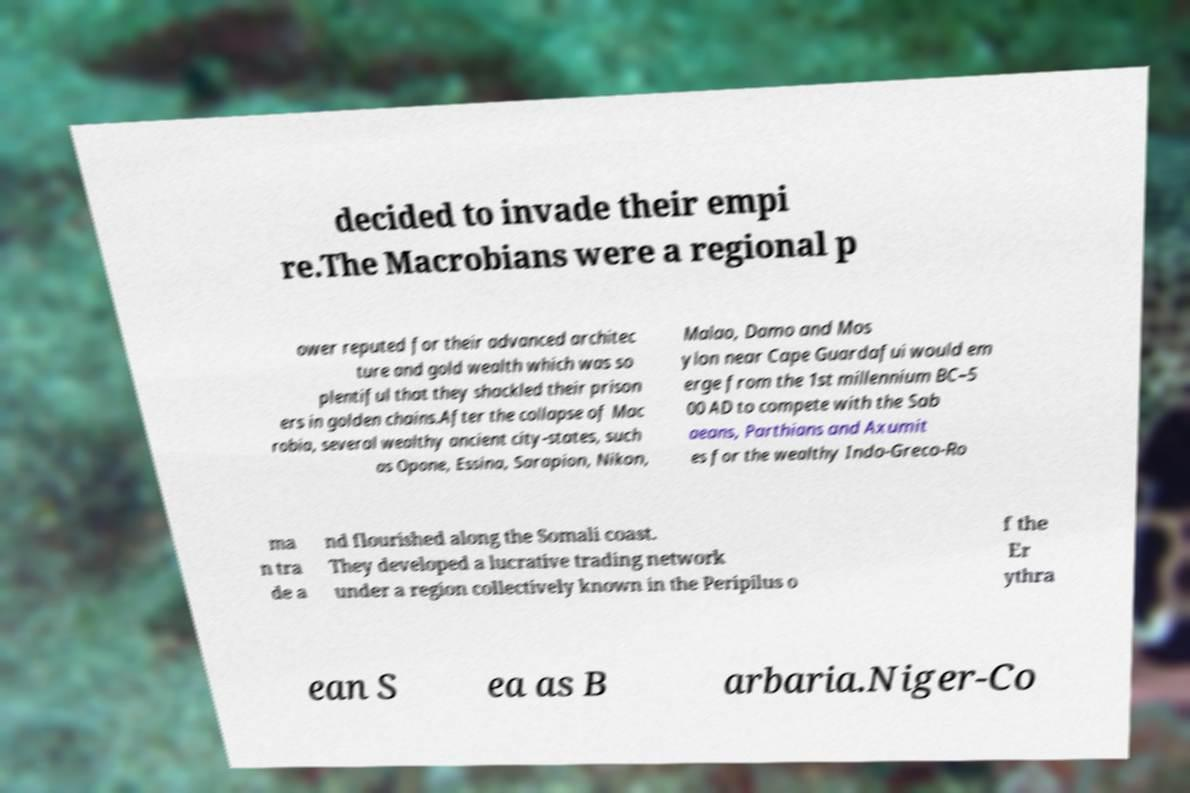What messages or text are displayed in this image? I need them in a readable, typed format. decided to invade their empi re.The Macrobians were a regional p ower reputed for their advanced architec ture and gold wealth which was so plentiful that they shackled their prison ers in golden chains.After the collapse of Mac robia, several wealthy ancient city-states, such as Opone, Essina, Sarapion, Nikon, Malao, Damo and Mos ylon near Cape Guardafui would em erge from the 1st millennium BC–5 00 AD to compete with the Sab aeans, Parthians and Axumit es for the wealthy Indo-Greco-Ro ma n tra de a nd flourished along the Somali coast. They developed a lucrative trading network under a region collectively known in the Peripilus o f the Er ythra ean S ea as B arbaria.Niger-Co 